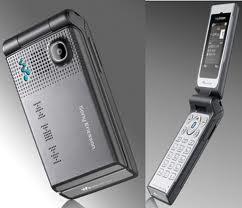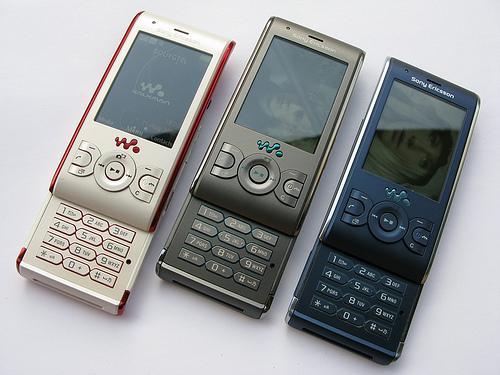The first image is the image on the left, the second image is the image on the right. For the images shown, is this caption "Three phones are laid out neatly side by side in one of the pictures." true? Answer yes or no. Yes. The first image is the image on the left, the second image is the image on the right. For the images displayed, is the sentence "The image on the left shows an opened flip phone." factually correct? Answer yes or no. Yes. 